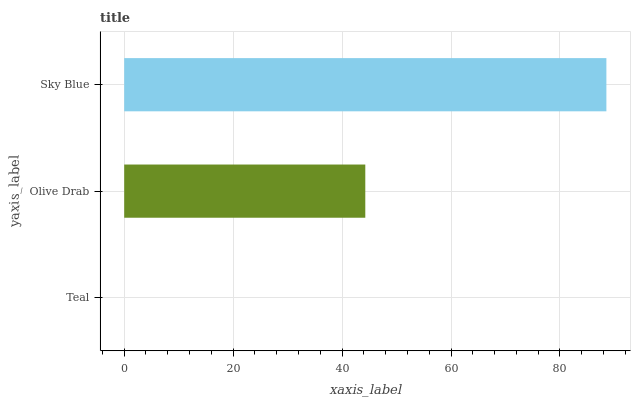Is Teal the minimum?
Answer yes or no. Yes. Is Sky Blue the maximum?
Answer yes or no. Yes. Is Olive Drab the minimum?
Answer yes or no. No. Is Olive Drab the maximum?
Answer yes or no. No. Is Olive Drab greater than Teal?
Answer yes or no. Yes. Is Teal less than Olive Drab?
Answer yes or no. Yes. Is Teal greater than Olive Drab?
Answer yes or no. No. Is Olive Drab less than Teal?
Answer yes or no. No. Is Olive Drab the high median?
Answer yes or no. Yes. Is Olive Drab the low median?
Answer yes or no. Yes. Is Teal the high median?
Answer yes or no. No. Is Teal the low median?
Answer yes or no. No. 